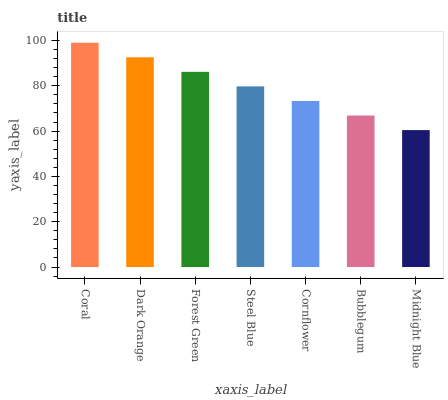Is Midnight Blue the minimum?
Answer yes or no. Yes. Is Coral the maximum?
Answer yes or no. Yes. Is Dark Orange the minimum?
Answer yes or no. No. Is Dark Orange the maximum?
Answer yes or no. No. Is Coral greater than Dark Orange?
Answer yes or no. Yes. Is Dark Orange less than Coral?
Answer yes or no. Yes. Is Dark Orange greater than Coral?
Answer yes or no. No. Is Coral less than Dark Orange?
Answer yes or no. No. Is Steel Blue the high median?
Answer yes or no. Yes. Is Steel Blue the low median?
Answer yes or no. Yes. Is Bubblegum the high median?
Answer yes or no. No. Is Bubblegum the low median?
Answer yes or no. No. 